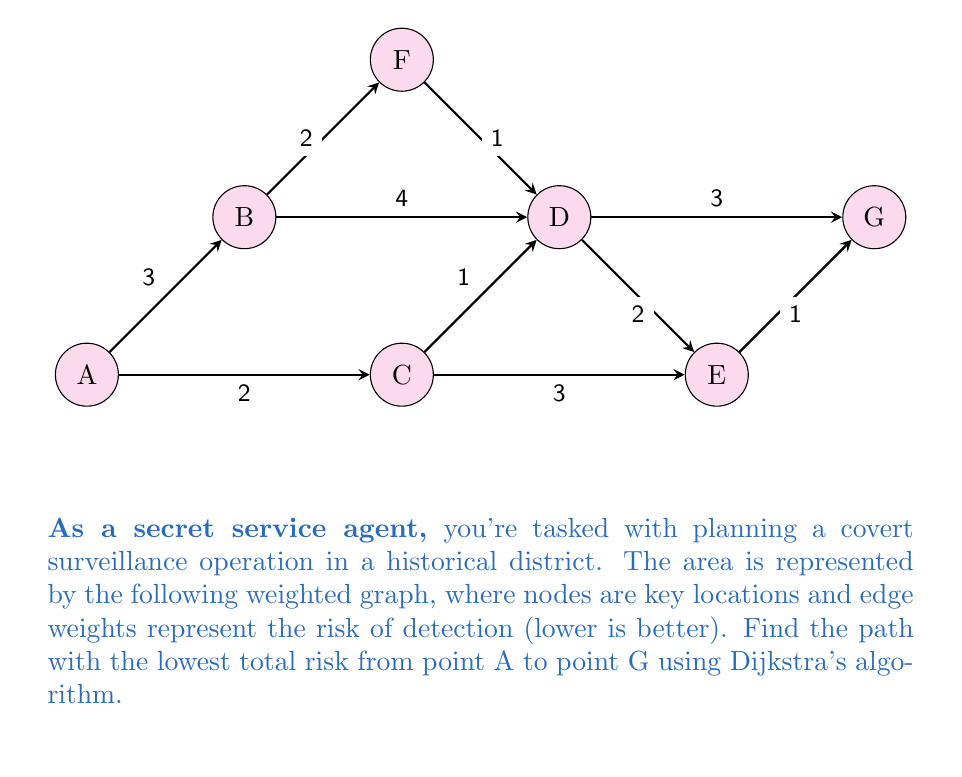Could you help me with this problem? To solve this problem, we'll use Dijkstra's algorithm to find the shortest path from A to G. The algorithm works as follows:

1) Initialize:
   - Set distance to A as 0
   - Set distance to all other nodes as infinity
   - Set all nodes as unvisited

2) For the current node (starting with A), consider all unvisited neighbors and calculate their tentative distances.
3) Mark the current node as visited. A visited node will not be checked again.
4) If the destination node (G) has been marked visited, we're done.
5) Otherwise, select the unvisited node with the smallest tentative distance and set it as the new current node. Go back to step 2.

Let's apply the algorithm:

Step 1: Initialize
A: 0, B: ∞, C: ∞, D: ∞, E: ∞, F: ∞, G: ∞
Current node: A

Step 2-3: Consider A's neighbors
B: min(∞, 0+3) = 3
C: min(∞, 0+2) = 2
Mark A as visited

Step 4-5: Select C (smallest distance)
Current node: C

Step 2-3: Consider C's neighbors
D: min(∞, 2+1) = 3
E: min(∞, 2+3) = 5
Mark C as visited

Step 4-5: Select D (smallest distance)
Current node: D

Step 2-3: Consider D's neighbors
E: min(5, 3+2) = 5
G: min(∞, 3+3) = 6
B: Already visited
F: Not directly connected
Mark D as visited

Step 4-5: Select E (smallest distance)
Current node: E

Step 2-3: Consider E's neighbors
G: min(6, 5+1) = 6
Mark E as visited

Step 4-5: Select G (smallest distance)
Current node: G

G is our destination, so we're done. The shortest path is A → C → D → E → G with a total risk of 6.
Answer: A → C → D → E → G, total risk = 6 